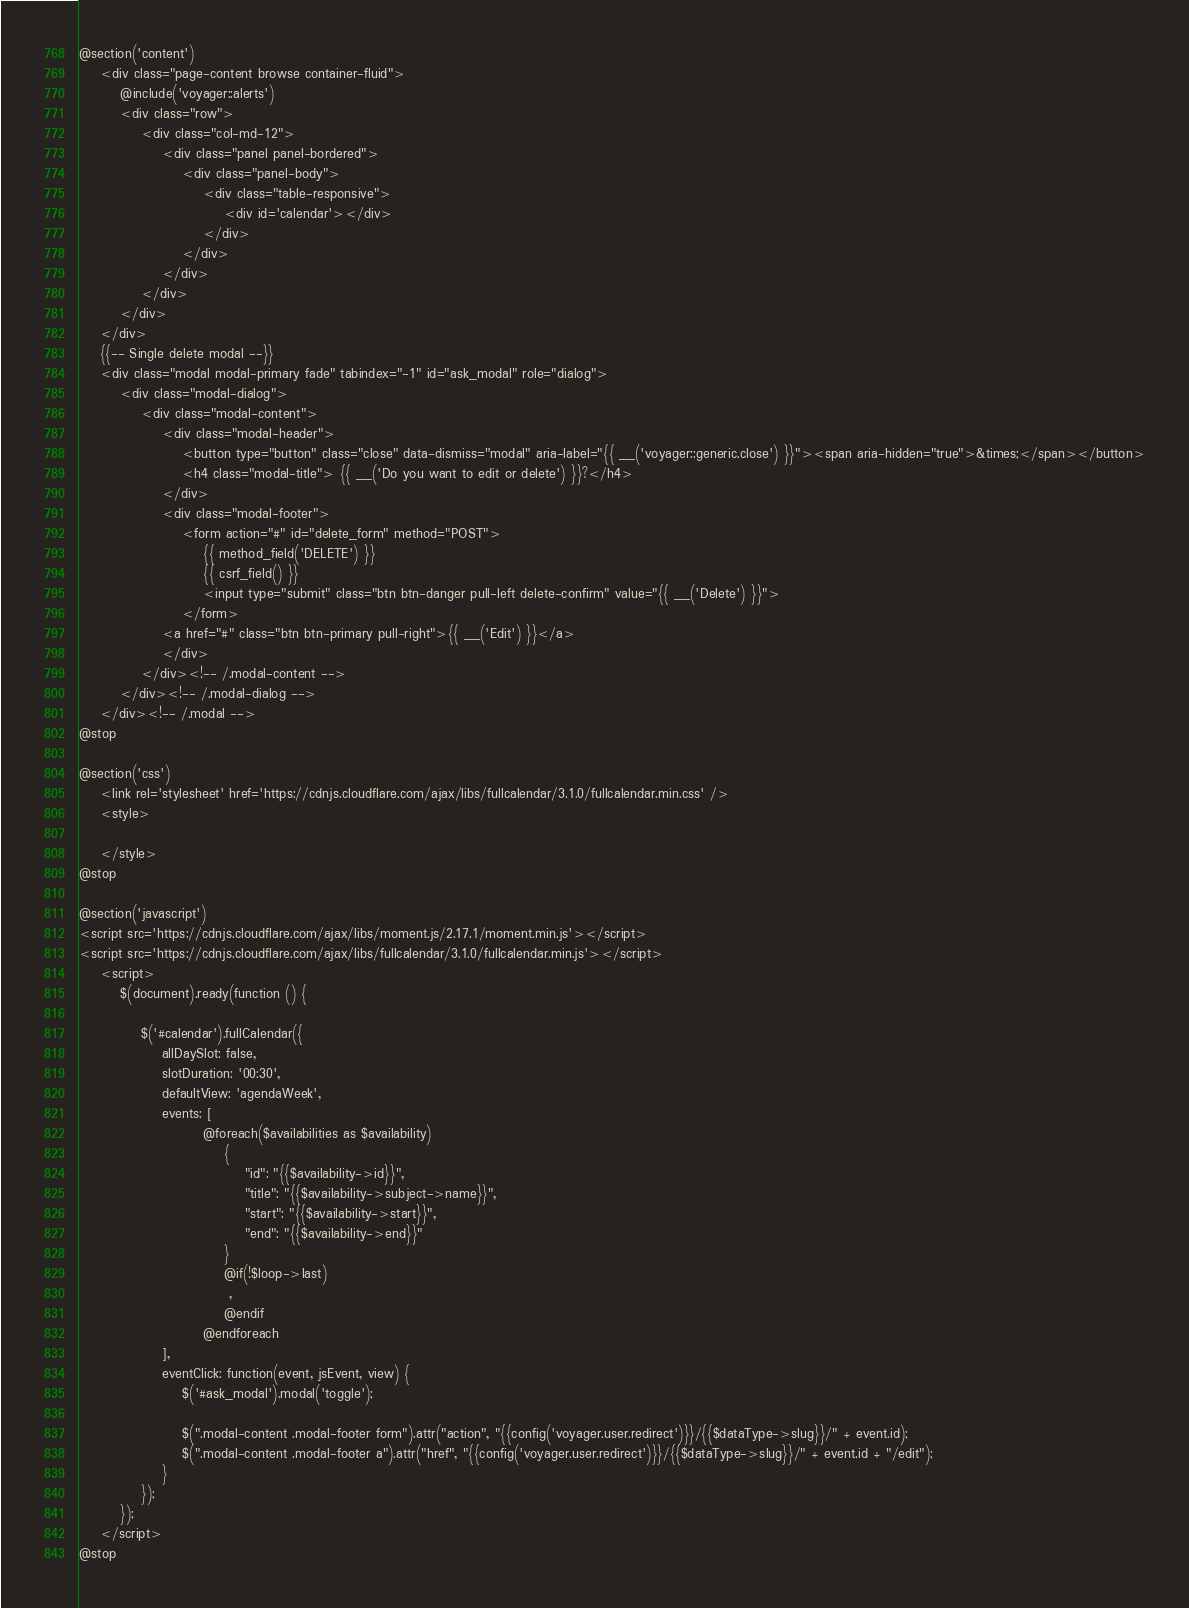<code> <loc_0><loc_0><loc_500><loc_500><_PHP_>@section('content')
    <div class="page-content browse container-fluid">
        @include('voyager::alerts')
        <div class="row">
            <div class="col-md-12">
                <div class="panel panel-bordered">
                    <div class="panel-body">
                        <div class="table-responsive">
                            <div id='calendar'></div>
                        </div>
                    </div>
                </div>
            </div>
        </div>
    </div>
    {{-- Single delete modal --}}
    <div class="modal modal-primary fade" tabindex="-1" id="ask_modal" role="dialog">
        <div class="modal-dialog">
            <div class="modal-content">
                <div class="modal-header">
                    <button type="button" class="close" data-dismiss="modal" aria-label="{{ __('voyager::generic.close') }}"><span aria-hidden="true">&times;</span></button>
                    <h4 class="modal-title"> {{ __('Do you want to edit or delete') }}?</h4>
                </div>
                <div class="modal-footer">
                    <form action="#" id="delete_form" method="POST">
                        {{ method_field('DELETE') }}
                        {{ csrf_field() }}
                        <input type="submit" class="btn btn-danger pull-left delete-confirm" value="{{ __('Delete') }}">
                    </form>
                <a href="#" class="btn btn-primary pull-right">{{ __('Edit') }}</a>
                </div>
            </div><!-- /.modal-content -->
        </div><!-- /.modal-dialog -->
    </div><!-- /.modal -->
@stop

@section('css')
    <link rel='stylesheet' href='https://cdnjs.cloudflare.com/ajax/libs/fullcalendar/3.1.0/fullcalendar.min.css' />
    <style>

    </style>
@stop

@section('javascript')
<script src='https://cdnjs.cloudflare.com/ajax/libs/moment.js/2.17.1/moment.min.js'></script>
<script src='https://cdnjs.cloudflare.com/ajax/libs/fullcalendar/3.1.0/fullcalendar.min.js'></script>
    <script>
        $(document).ready(function () {

            $('#calendar').fullCalendar({
                allDaySlot: false,
                slotDuration: '00:30',
                defaultView: 'agendaWeek',
                events: [
                        @foreach($availabilities as $availability)
                            {
                                "id": "{{$availability->id}}",
                                "title": "{{$availability->subject->name}}",
                                "start": "{{$availability->start}}",
                                "end": "{{$availability->end}}"
                            }
                            @if(!$loop->last)
                             ,
                            @endif
                        @endforeach
                ],
                eventClick: function(event, jsEvent, view) {
                    $('#ask_modal').modal('toggle');

                    $(".modal-content .modal-footer form").attr("action", "{{config('voyager.user.redirect')}}/{{$dataType->slug}}/" + event.id);
                    $(".modal-content .modal-footer a").attr("href", "{{config('voyager.user.redirect')}}/{{$dataType->slug}}/" + event.id + "/edit");
                }
            });
        });
    </script>
@stop
</code> 